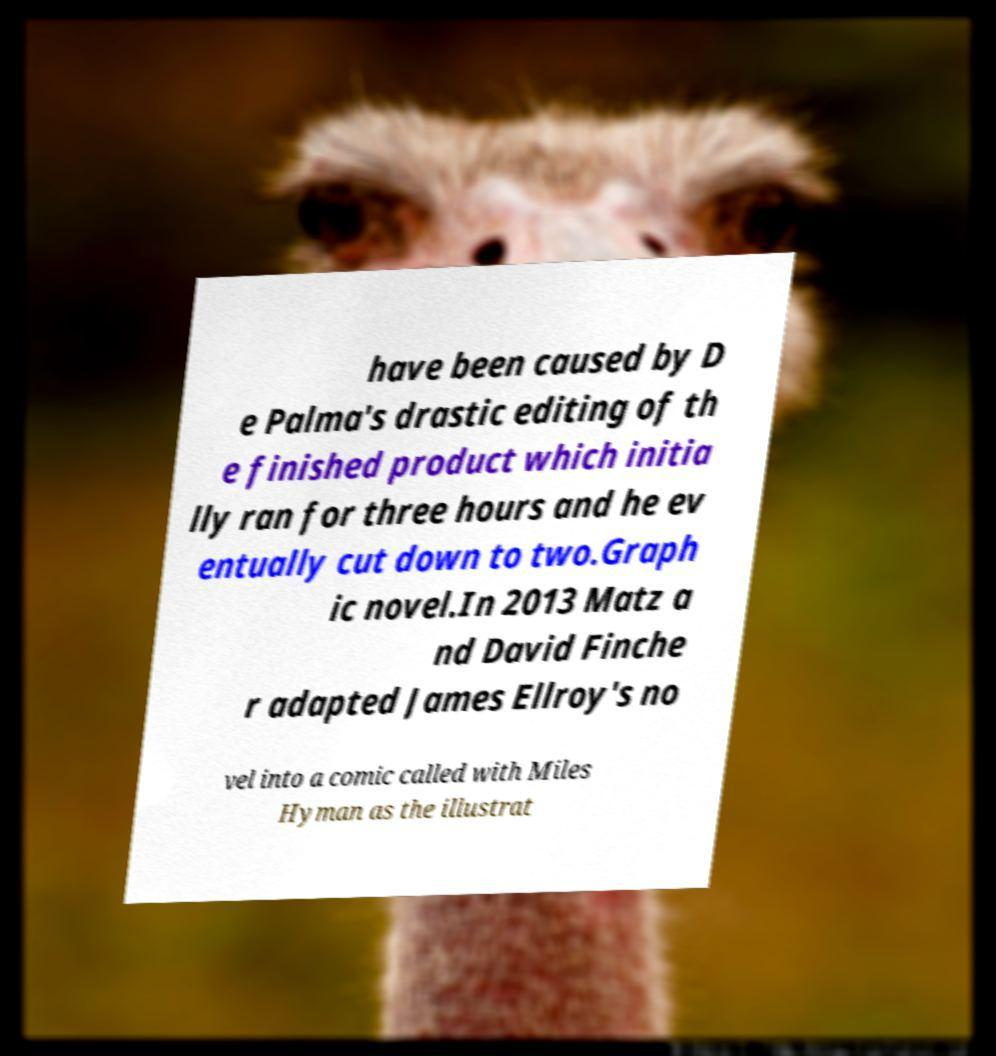I need the written content from this picture converted into text. Can you do that? have been caused by D e Palma's drastic editing of th e finished product which initia lly ran for three hours and he ev entually cut down to two.Graph ic novel.In 2013 Matz a nd David Finche r adapted James Ellroy's no vel into a comic called with Miles Hyman as the illustrat 